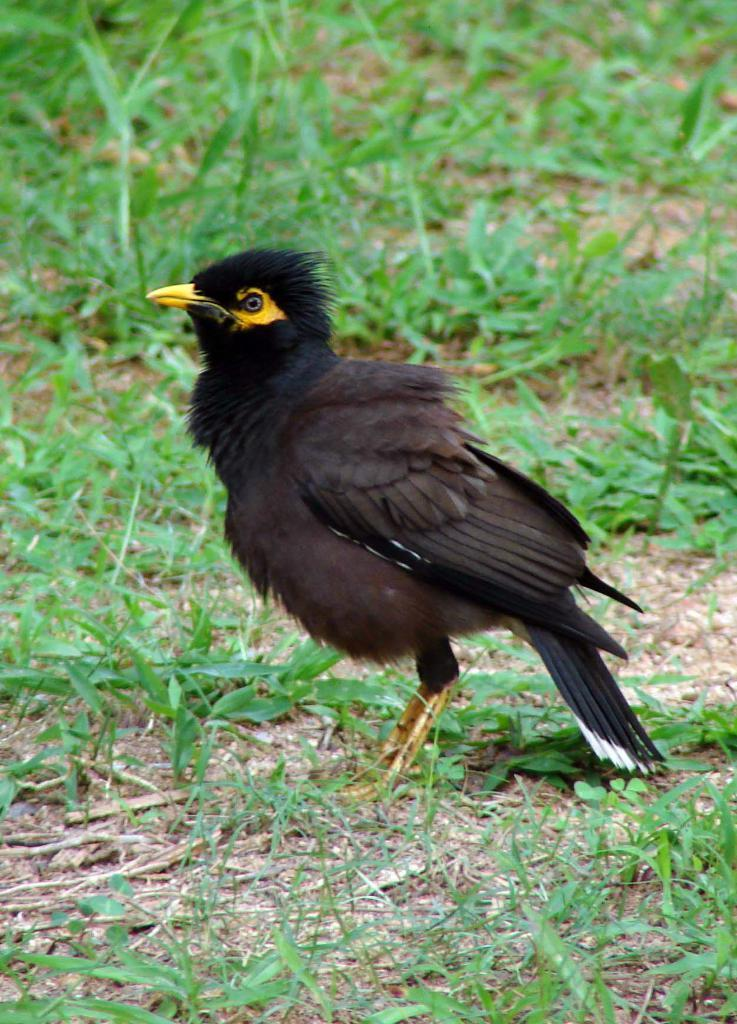What is the main subject in the center of the image? There is a bird in the center of the image. What type of natural environment is visible at the bottom of the image? There is grass at the bottom of the image. What type of reward is the bird holding in the image? There is no reward present in the image; it features a bird in the grass. What type of sheet is covering the bird in the image? There is no sheet covering the bird in the image; it is visible in the grass. 